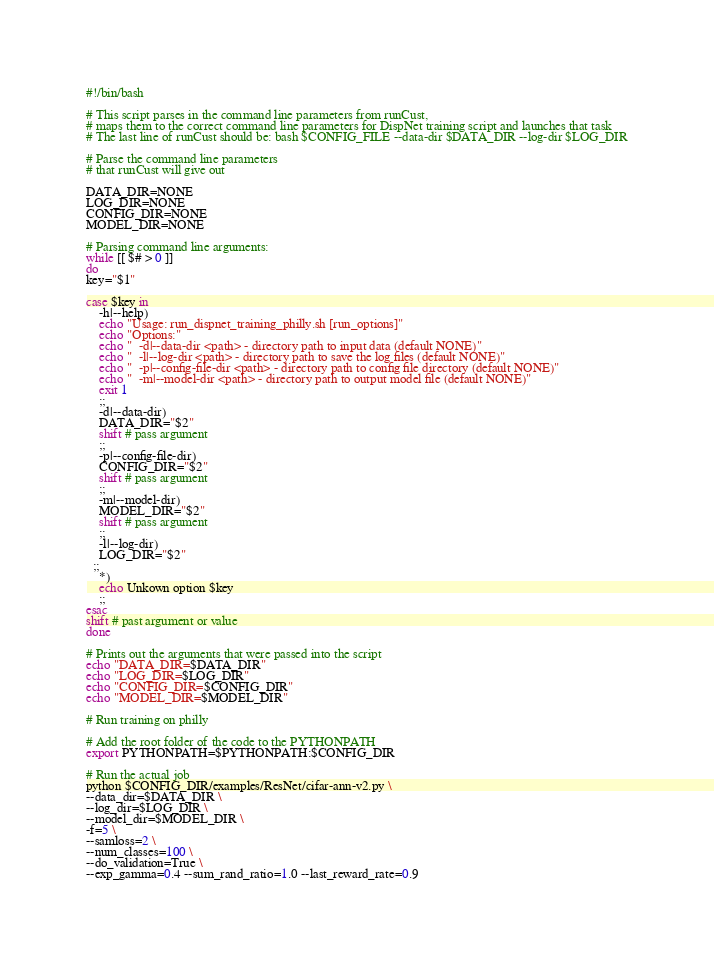Convert code to text. <code><loc_0><loc_0><loc_500><loc_500><_Bash_>#!/bin/bash

# This script parses in the command line parameters from runCust, 
# maps them to the correct command line parameters for DispNet training script and launches that task
# The last line of runCust should be: bash $CONFIG_FILE --data-dir $DATA_DIR --log-dir $LOG_DIR

# Parse the command line parameters
# that runCust will give out

DATA_DIR=NONE
LOG_DIR=NONE
CONFIG_DIR=NONE
MODEL_DIR=NONE

# Parsing command line arguments:
while [[ $# > 0 ]]
do
key="$1"

case $key in
    -h|--help)
    echo "Usage: run_dispnet_training_philly.sh [run_options]"
    echo "Options:"
    echo "  -d|--data-dir <path> - directory path to input data (default NONE)"
    echo "  -l|--log-dir <path> - directory path to save the log files (default NONE)"
    echo "  -p|--config-file-dir <path> - directory path to config file directory (default NONE)"
    echo "  -m|--model-dir <path> - directory path to output model file (default NONE)"
    exit 1
    ;;
    -d|--data-dir)
    DATA_DIR="$2"
    shift # pass argument
    ;;
    -p|--config-file-dir)
    CONFIG_DIR="$2"
    shift # pass argument
    ;;
    -m|--model-dir)
    MODEL_DIR="$2"
    shift # pass argument
    ;;
    -l|--log-dir)
    LOG_DIR="$2"
  ;;
    *)
    echo Unkown option $key
    ;;
esac
shift # past argument or value
done

# Prints out the arguments that were passed into the script
echo "DATA_DIR=$DATA_DIR"
echo "LOG_DIR=$LOG_DIR"
echo "CONFIG_DIR=$CONFIG_DIR"
echo "MODEL_DIR=$MODEL_DIR"

# Run training on philly

# Add the root folder of the code to the PYTHONPATH
export PYTHONPATH=$PYTHONPATH:$CONFIG_DIR

# Run the actual job
python $CONFIG_DIR/examples/ResNet/cifar-ann-v2.py \
--data_dir=$DATA_DIR \
--log_dir=$LOG_DIR \
--model_dir=$MODEL_DIR \
-f=5 \
--samloss=2 \
--num_classes=100 \
--do_validation=True \
--exp_gamma=0.4 --sum_rand_ratio=1.0 --last_reward_rate=0.9
</code> 